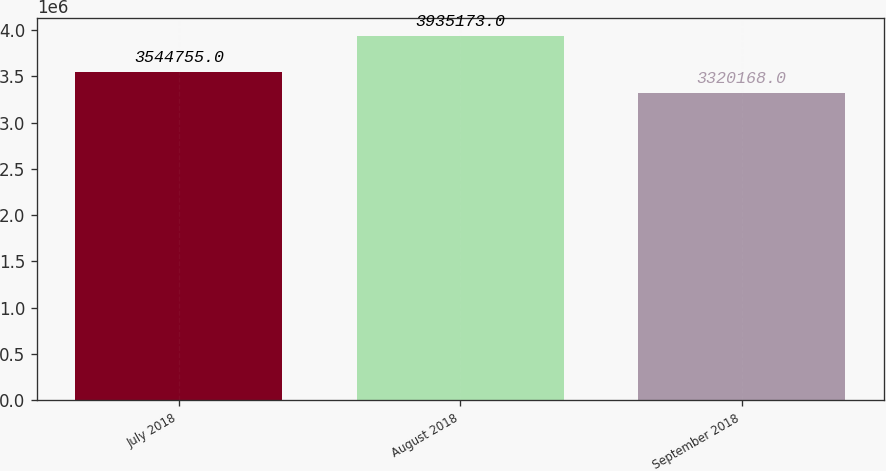<chart> <loc_0><loc_0><loc_500><loc_500><bar_chart><fcel>July 2018<fcel>August 2018<fcel>September 2018<nl><fcel>3.54476e+06<fcel>3.93517e+06<fcel>3.32017e+06<nl></chart> 